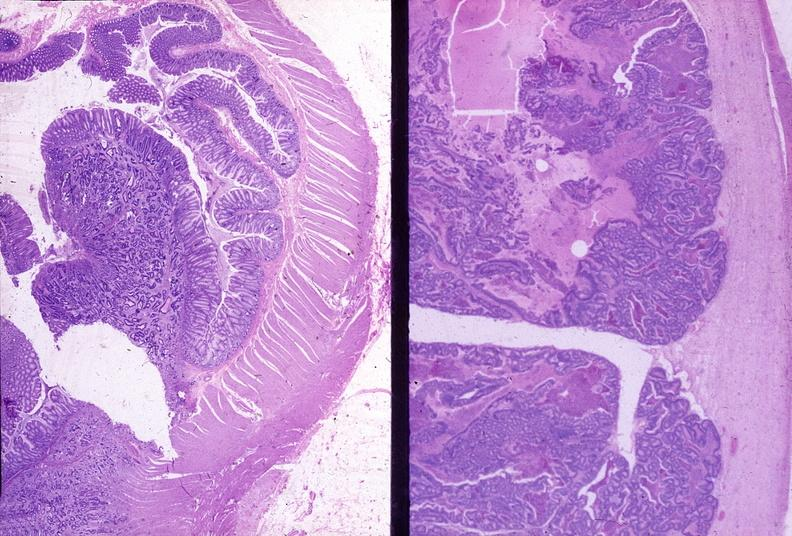what is present?
Answer the question using a single word or phrase. Gastrointestinal 